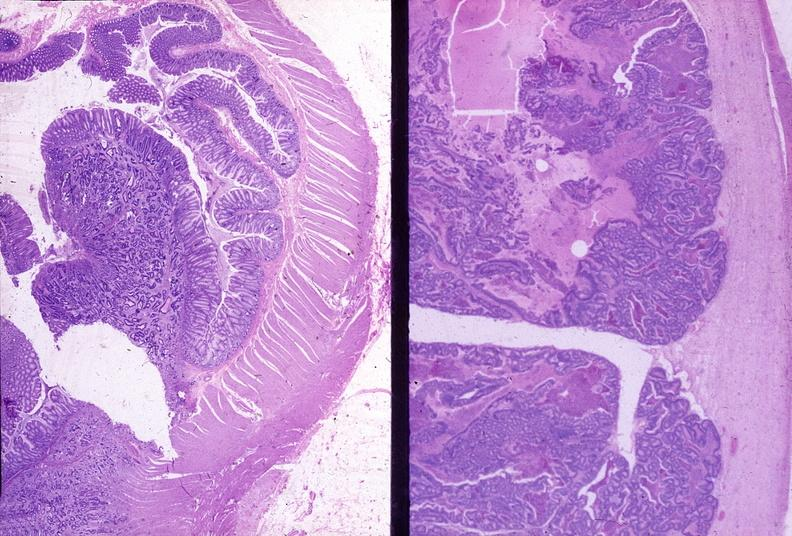what is present?
Answer the question using a single word or phrase. Gastrointestinal 